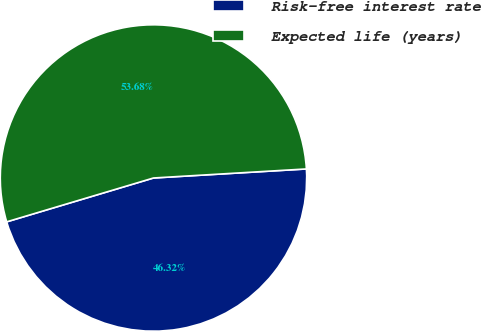<chart> <loc_0><loc_0><loc_500><loc_500><pie_chart><fcel>Risk-free interest rate<fcel>Expected life (years)<nl><fcel>46.32%<fcel>53.68%<nl></chart> 